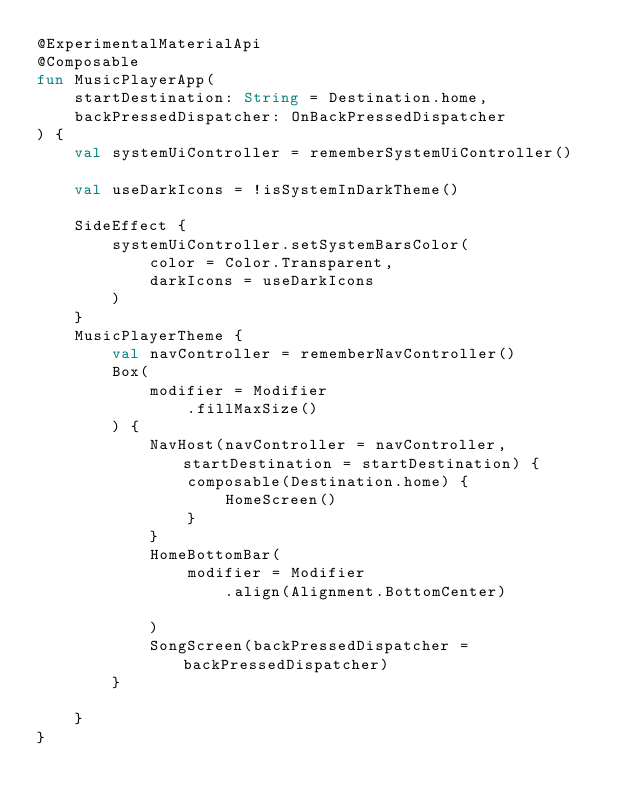<code> <loc_0><loc_0><loc_500><loc_500><_Kotlin_>@ExperimentalMaterialApi
@Composable
fun MusicPlayerApp(
    startDestination: String = Destination.home,
    backPressedDispatcher: OnBackPressedDispatcher
) {
    val systemUiController = rememberSystemUiController()

    val useDarkIcons = !isSystemInDarkTheme()

    SideEffect {
        systemUiController.setSystemBarsColor(
            color = Color.Transparent,
            darkIcons = useDarkIcons
        )
    }
    MusicPlayerTheme {
        val navController = rememberNavController()
        Box(
            modifier = Modifier
                .fillMaxSize()
        ) {
            NavHost(navController = navController, startDestination = startDestination) {
                composable(Destination.home) {
                    HomeScreen()
                }
            }
            HomeBottomBar(
                modifier = Modifier
                    .align(Alignment.BottomCenter)

            )
            SongScreen(backPressedDispatcher = backPressedDispatcher)
        }

    }
}

</code> 